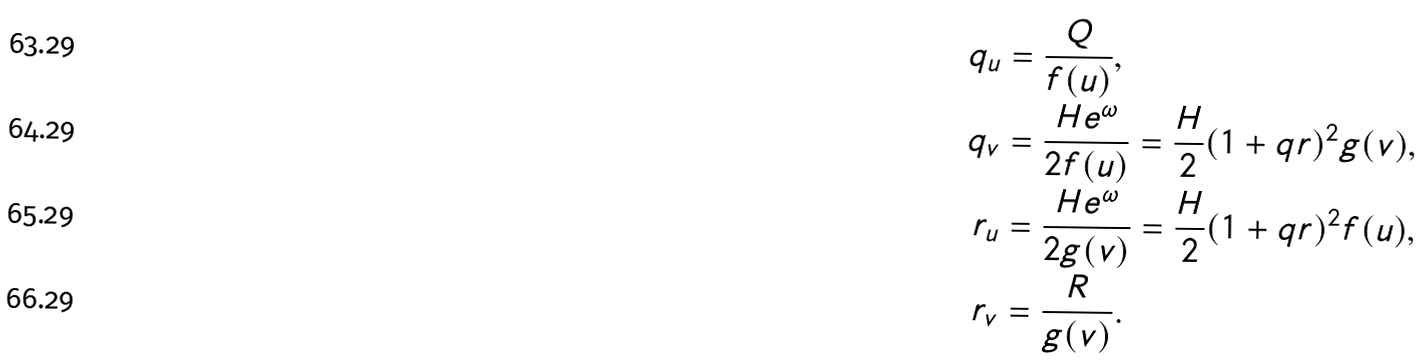Convert formula to latex. <formula><loc_0><loc_0><loc_500><loc_500>q _ { u } & = \frac { Q } { f ( u ) } , \\ q _ { v } & = \frac { H e ^ { \omega } } { 2 f ( u ) } = \frac { H } { 2 } ( 1 + q r ) ^ { 2 } g ( v ) , \\ r _ { u } & = \frac { H e ^ { \omega } } { 2 g ( v ) } = \frac { H } { 2 } ( 1 + q r ) ^ { 2 } f ( u ) , \\ r _ { v } & = \frac { R } { g ( v ) } .</formula> 